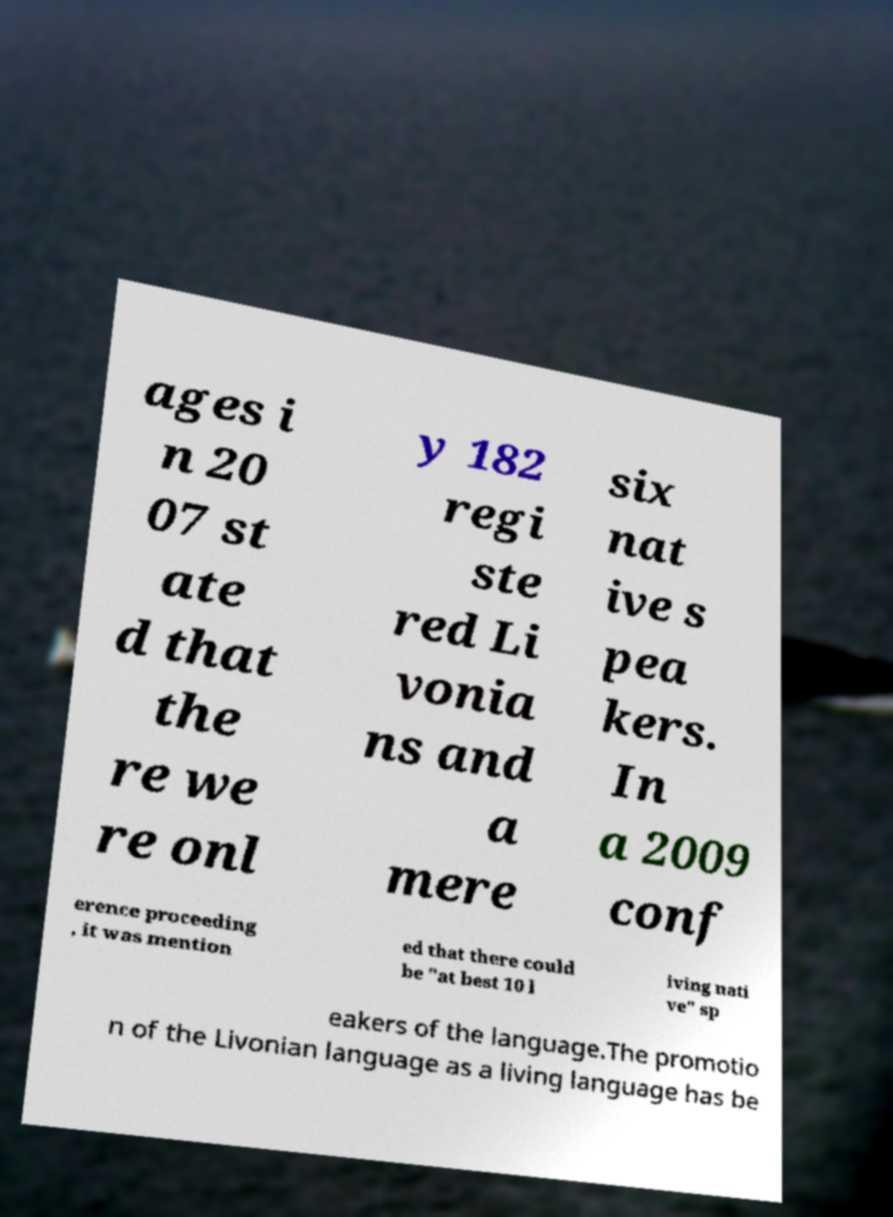Could you extract and type out the text from this image? ages i n 20 07 st ate d that the re we re onl y 182 regi ste red Li vonia ns and a mere six nat ive s pea kers. In a 2009 conf erence proceeding , it was mention ed that there could be "at best 10 l iving nati ve" sp eakers of the language.The promotio n of the Livonian language as a living language has be 